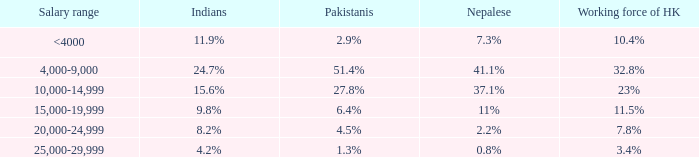If the Indians are 8.2%, what is the salary range? 20,000-24,999. 